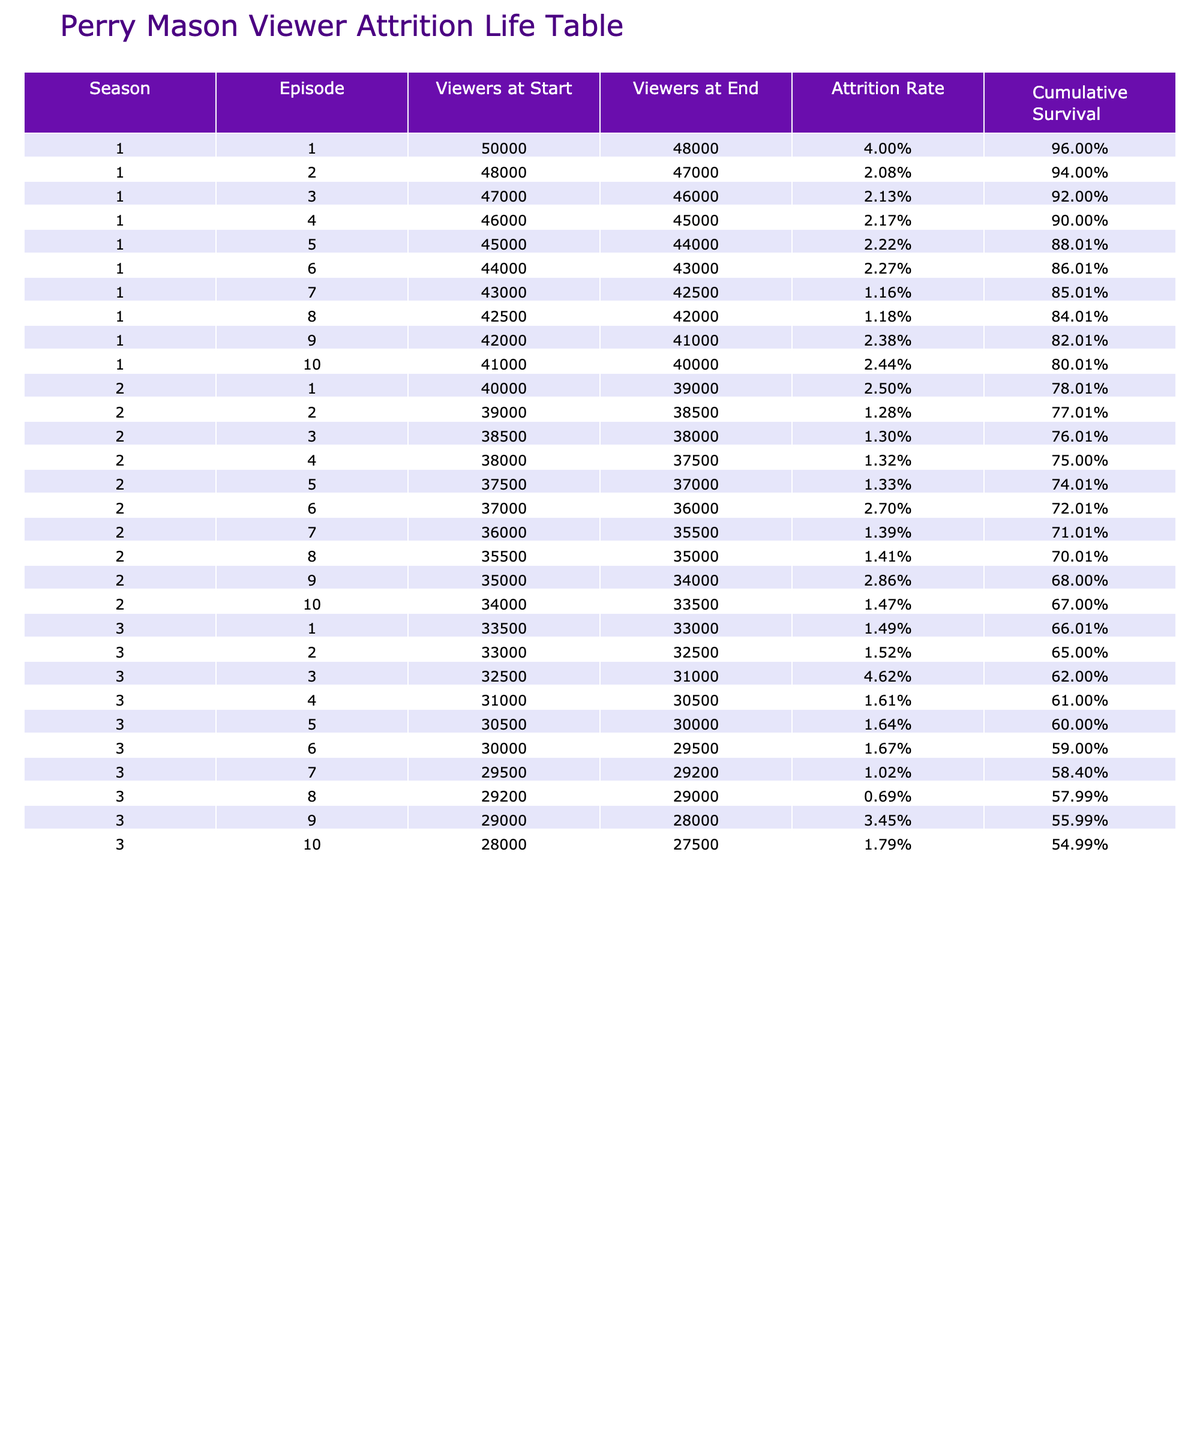What is the attrition rate of Season 1, Episode 5? The table indicates that the attrition rate for Season 1, Episode 5 is listed under the "Attrition Rate" column. By looking at that row, we can see it is 2.22%.
Answer: 2.22% What was the number of viewers at the start of Season 3, Episode 3? Referring to the table, we can find the row for Season 3, Episode 3. The viewers at the start of that episode are listed as 32,500.
Answer: 32,500 Which episode had the highest attrition rate in Season 1? To find the episode with the highest attrition rate in Season 1, we compare the "Attrition Rate" values for all episodes in that season. The highest attrition rate is 4.00% for Episode 1.
Answer: Episode 1 Is the attrition rate for Season 2, Episode 6 higher than that for Season 1, Episode 10? Checking the values, Season 2, Episode 6 has an attrition rate of 2.70%, while Season 1, Episode 10 has an attrition rate of 2.44%. We see that 2.70% is greater than 2.44%, so the statement is true.
Answer: Yes What is the cumulative survival rate after Season 1, Episode 4? The cumulative survival rate is calculated by applying the attrition rates consecutively to the initial viewer count. For Episode 4, the attrition rates of episodes 1 through 4 are used to find the cumulative survival: 100% * (1-0.04) * (1-0.0208) * (1-0.0213) * (1-0.0217) = about 92.21%.
Answer: 92.21% What was the total viewer loss from Season 1, Episode 1 to Season 3, Episode 10? First, calculate the viewers at the beginning and end of these episodes. Episode 1 starts with 50,000 and ends with 48,000; the loss there is 2,000. Episode 10 in Season 3 starts with 28,000 and ends with 27,500; the loss there is 500. Adding these gives a total loss of 2,500 viewers across the episodes.
Answer: 2,500 What is the average attrition rate for all episodes in Season 2? To find the average attrition rate for Season 2, we add the attrition rates of each episode: (2.50% + 1.28% + 1.30% + 1.32% + 1.33% + 2.70% + 1.39% + 1.41% + 2.86% + 1.47%) = 17.56%. Dividing by 10 episodes gives an average of 1.756%.
Answer: 1.76% Was there a decrease in viewers from Season 1, Episode 1 to Season 1, Episode 10? By checking the viewers at the start, Episode 1 has 50,000 and Episode 10 has 40,000. Since 40,000 is less than 50,000, this indicates a decrease.
Answer: Yes Which season had fewer viewer losses on average: Season 1 or Season 3? The average loss can be calculated by summing the losses and then dividing by the number of episodes. Season 1 had losses of 2,000, 1,000, 1,000, 1,000, 1,000, 1,000, and 500 over 10 episodes, giving a total of 8,500 / 10 = 850 on average. For Season 3, the average loss is lower, about 1,080. This shows Season 3 had fewer viewer losses on average.
Answer: Season 3 